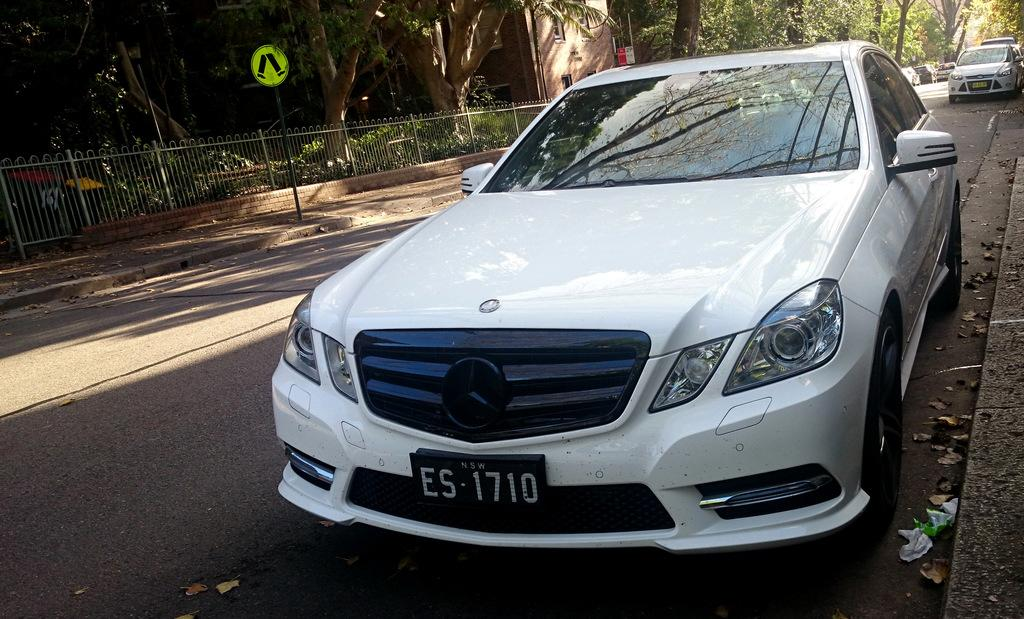What can be seen on the road in the image? There are cars on the road in the image. What is located in the background of the image? There is a sign board, a fence, trees, and a building in the background of the image. What type of crate can be seen on the coast in the image? There is no crate or coast present in the image; it features cars on a road with a background containing a sign board, fence, trees, and a building. 